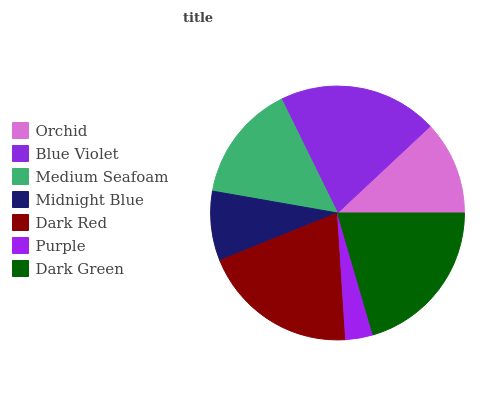Is Purple the minimum?
Answer yes or no. Yes. Is Dark Green the maximum?
Answer yes or no. Yes. Is Blue Violet the minimum?
Answer yes or no. No. Is Blue Violet the maximum?
Answer yes or no. No. Is Blue Violet greater than Orchid?
Answer yes or no. Yes. Is Orchid less than Blue Violet?
Answer yes or no. Yes. Is Orchid greater than Blue Violet?
Answer yes or no. No. Is Blue Violet less than Orchid?
Answer yes or no. No. Is Medium Seafoam the high median?
Answer yes or no. Yes. Is Medium Seafoam the low median?
Answer yes or no. Yes. Is Dark Green the high median?
Answer yes or no. No. Is Dark Red the low median?
Answer yes or no. No. 